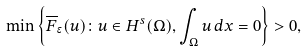Convert formula to latex. <formula><loc_0><loc_0><loc_500><loc_500>\min \left \{ \overline { F } _ { \epsilon } ( u ) \colon u \in H ^ { s } ( \Omega ) , \int _ { \Omega } { u \, d x } = 0 \right \} > 0 ,</formula> 